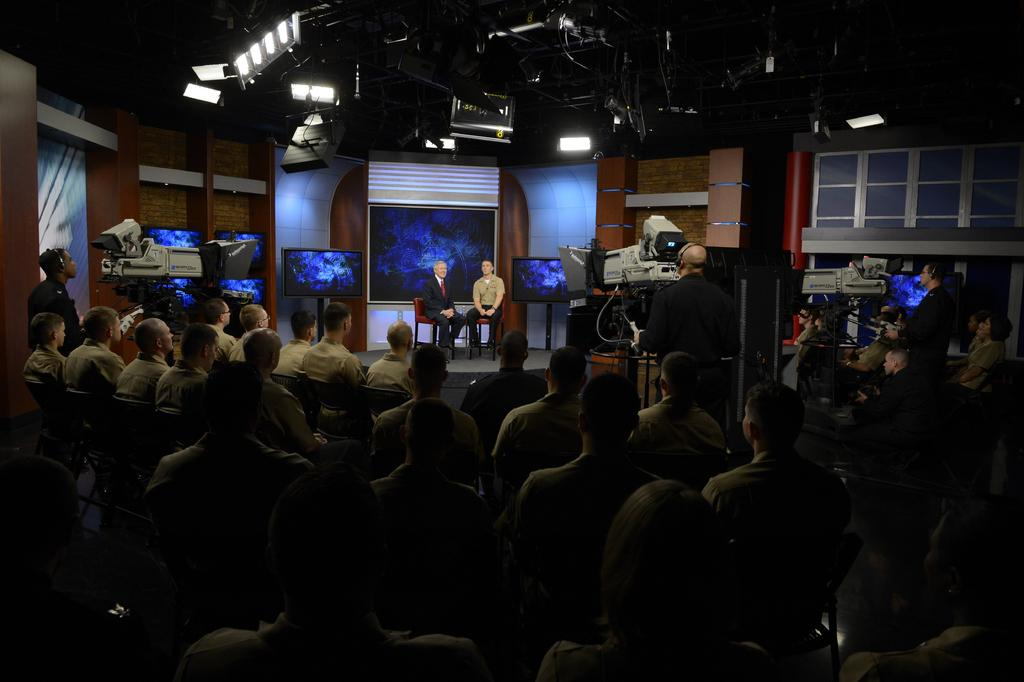How many people are sitting in chairs in the image? There are two persons sitting in chairs in the image. What objects are visible in the image besides the chairs? There are three cameras in the image. Are there any other people in the image besides the two persons sitting in chairs? Yes, there are people sitting in chairs in front of the two persons. Can you tell me how many horses are present in the image? There are no horses present in the image. What type of girl can be seen sitting in the chair next to the two persons? There is no girl present in the image; only two persons are sitting in chairs. 